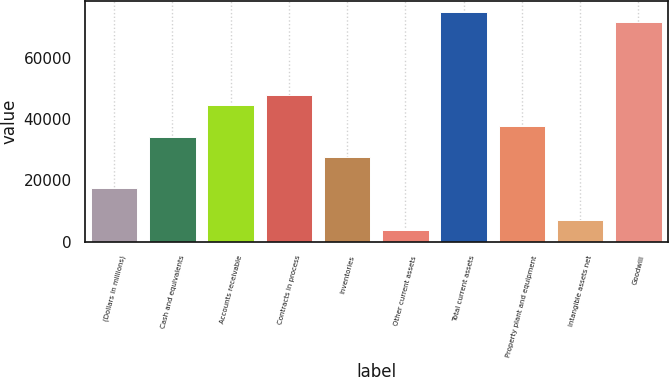<chart> <loc_0><loc_0><loc_500><loc_500><bar_chart><fcel>(Dollars in millions)<fcel>Cash and equivalents<fcel>Accounts receivable<fcel>Contracts in process<fcel>Inventories<fcel>Other current assets<fcel>Total current assets<fcel>Property plant and equipment<fcel>Intangible assets net<fcel>Goodwill<nl><fcel>17395.5<fcel>34309<fcel>44457.1<fcel>47839.8<fcel>27543.6<fcel>3864.7<fcel>74901.4<fcel>37691.7<fcel>7247.4<fcel>71518.7<nl></chart> 